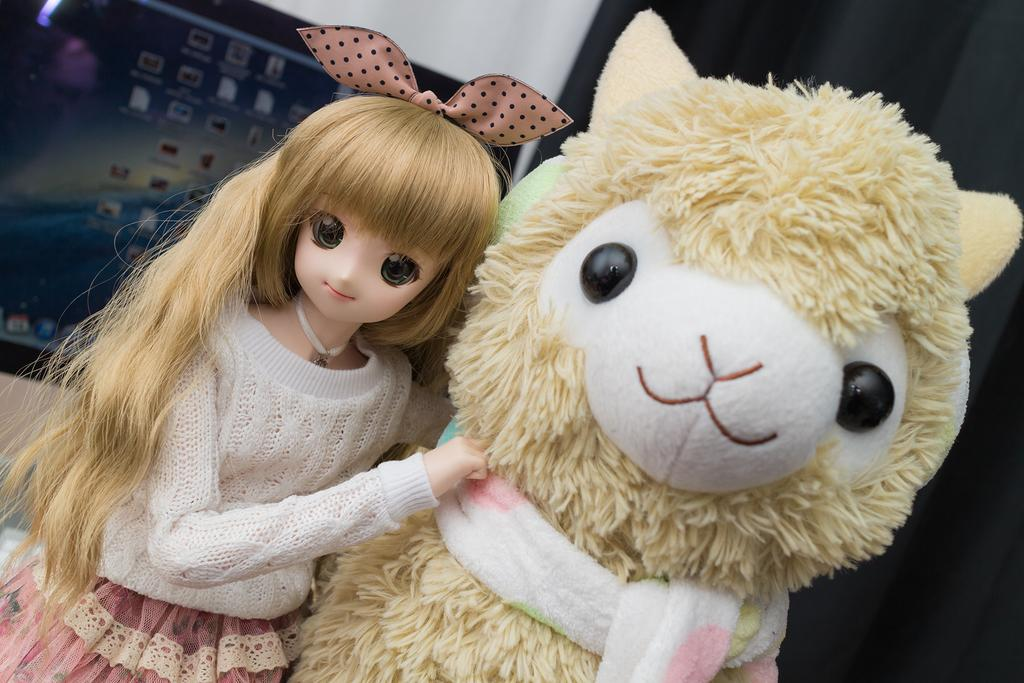What type of toys are present in the image? There is a doll and a soft toy in the image. What can be seen on the left side of the image? There is a monitor on the left side of the image. What color is the cloth on the right side of the image? The cloth on the right side of the image is black. What type of quill is being used to write on the monitor in the image? There is no quill present in the image, and the monitor is not being used for writing. 